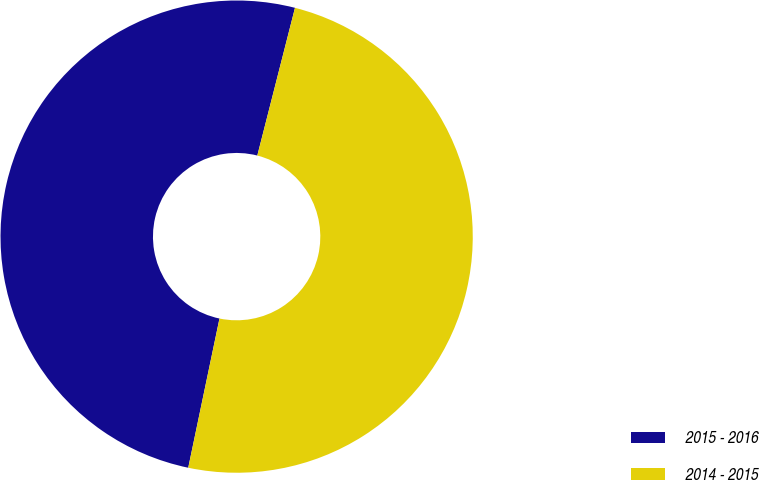<chart> <loc_0><loc_0><loc_500><loc_500><pie_chart><fcel>2015 - 2016<fcel>2014 - 2015<nl><fcel>50.69%<fcel>49.31%<nl></chart> 